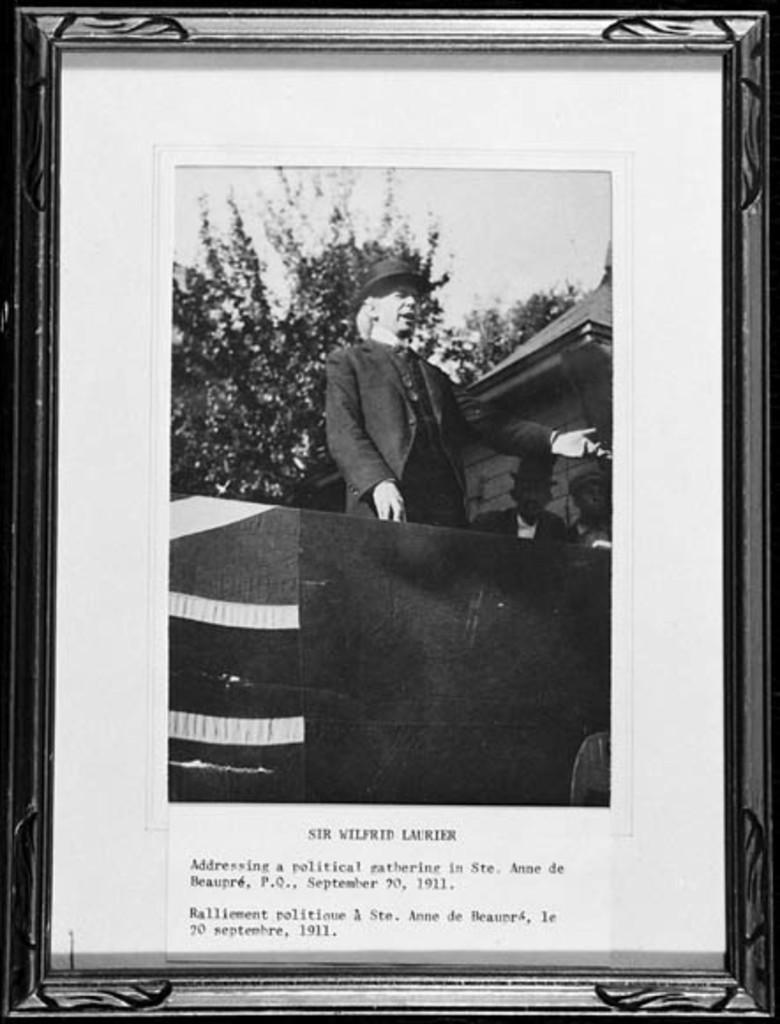<image>
Render a clear and concise summary of the photo. A framed black and white photo is titled Sir Wilfrid Laurier. 